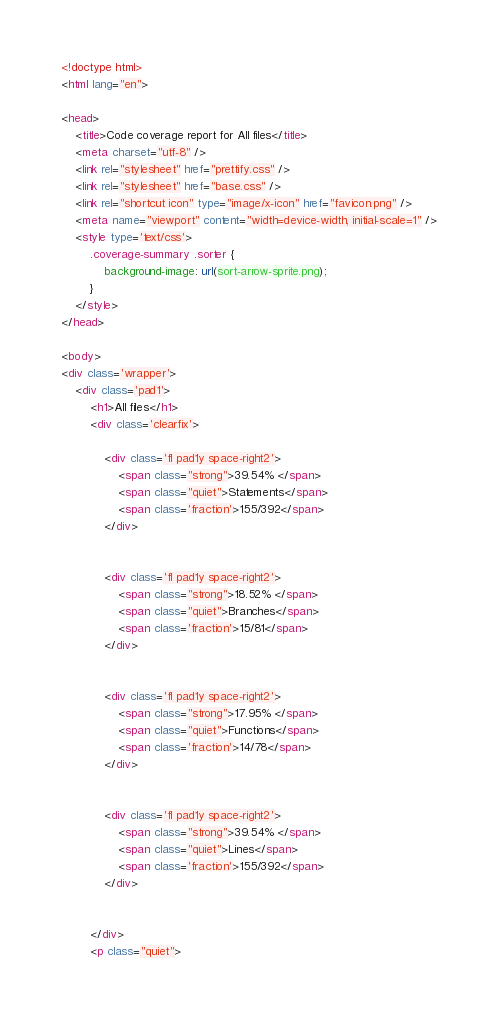<code> <loc_0><loc_0><loc_500><loc_500><_HTML_>
<!doctype html>
<html lang="en">

<head>
    <title>Code coverage report for All files</title>
    <meta charset="utf-8" />
    <link rel="stylesheet" href="prettify.css" />
    <link rel="stylesheet" href="base.css" />
    <link rel="shortcut icon" type="image/x-icon" href="favicon.png" />
    <meta name="viewport" content="width=device-width, initial-scale=1" />
    <style type='text/css'>
        .coverage-summary .sorter {
            background-image: url(sort-arrow-sprite.png);
        }
    </style>
</head>
    
<body>
<div class='wrapper'>
    <div class='pad1'>
        <h1>All files</h1>
        <div class='clearfix'>
            
            <div class='fl pad1y space-right2'>
                <span class="strong">39.54% </span>
                <span class="quiet">Statements</span>
                <span class='fraction'>155/392</span>
            </div>
        
            
            <div class='fl pad1y space-right2'>
                <span class="strong">18.52% </span>
                <span class="quiet">Branches</span>
                <span class='fraction'>15/81</span>
            </div>
        
            
            <div class='fl pad1y space-right2'>
                <span class="strong">17.95% </span>
                <span class="quiet">Functions</span>
                <span class='fraction'>14/78</span>
            </div>
        
            
            <div class='fl pad1y space-right2'>
                <span class="strong">39.54% </span>
                <span class="quiet">Lines</span>
                <span class='fraction'>155/392</span>
            </div>
        
            
        </div>
        <p class="quiet"></code> 